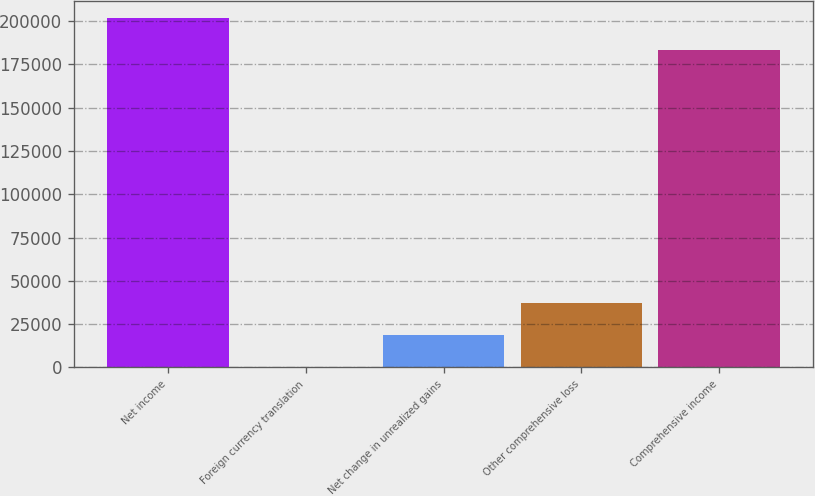Convert chart to OTSL. <chart><loc_0><loc_0><loc_500><loc_500><bar_chart><fcel>Net income<fcel>Foreign currency translation<fcel>Net change in unrealized gains<fcel>Other comprehensive loss<fcel>Comprehensive income<nl><fcel>201773<fcel>348<fcel>18732.1<fcel>37116.2<fcel>183389<nl></chart> 